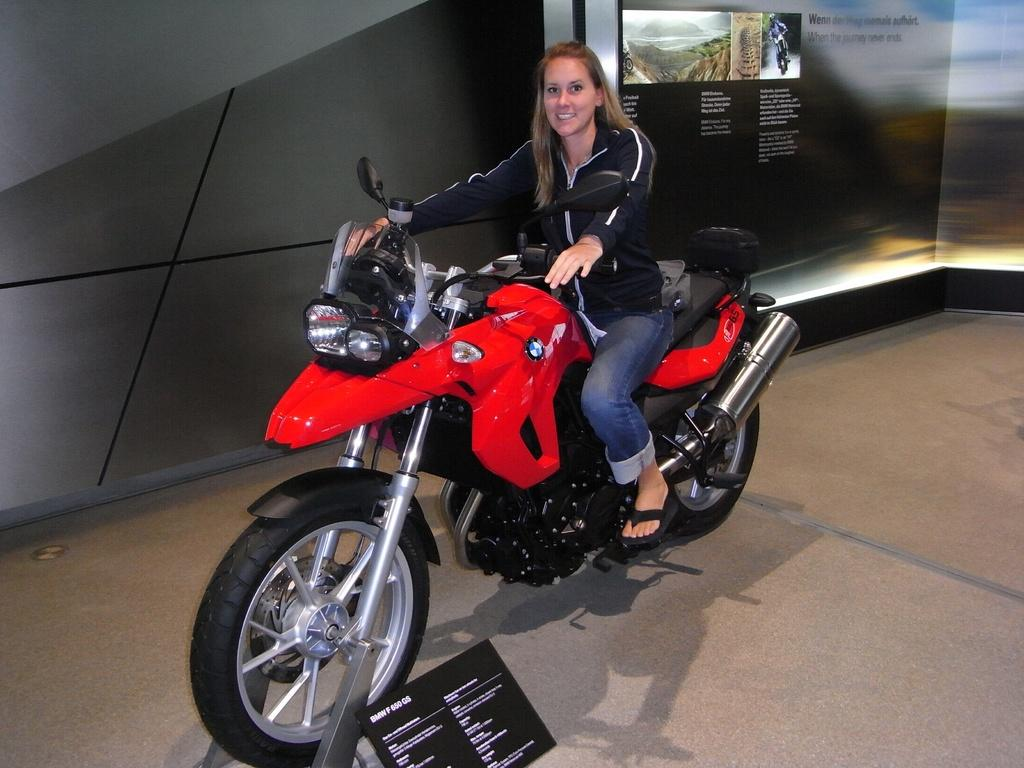Who is the main subject in the image? There is a woman in the image. What is the woman doing in the image? The woman is sitting on a bike. What can be seen in the background of the image? There is a mountain and the sky visible in the background of the image. What is the purpose of the woman's tongue in the image? There is no indication of the woman's tongue in the image, so it cannot be determined what its purpose might be. 